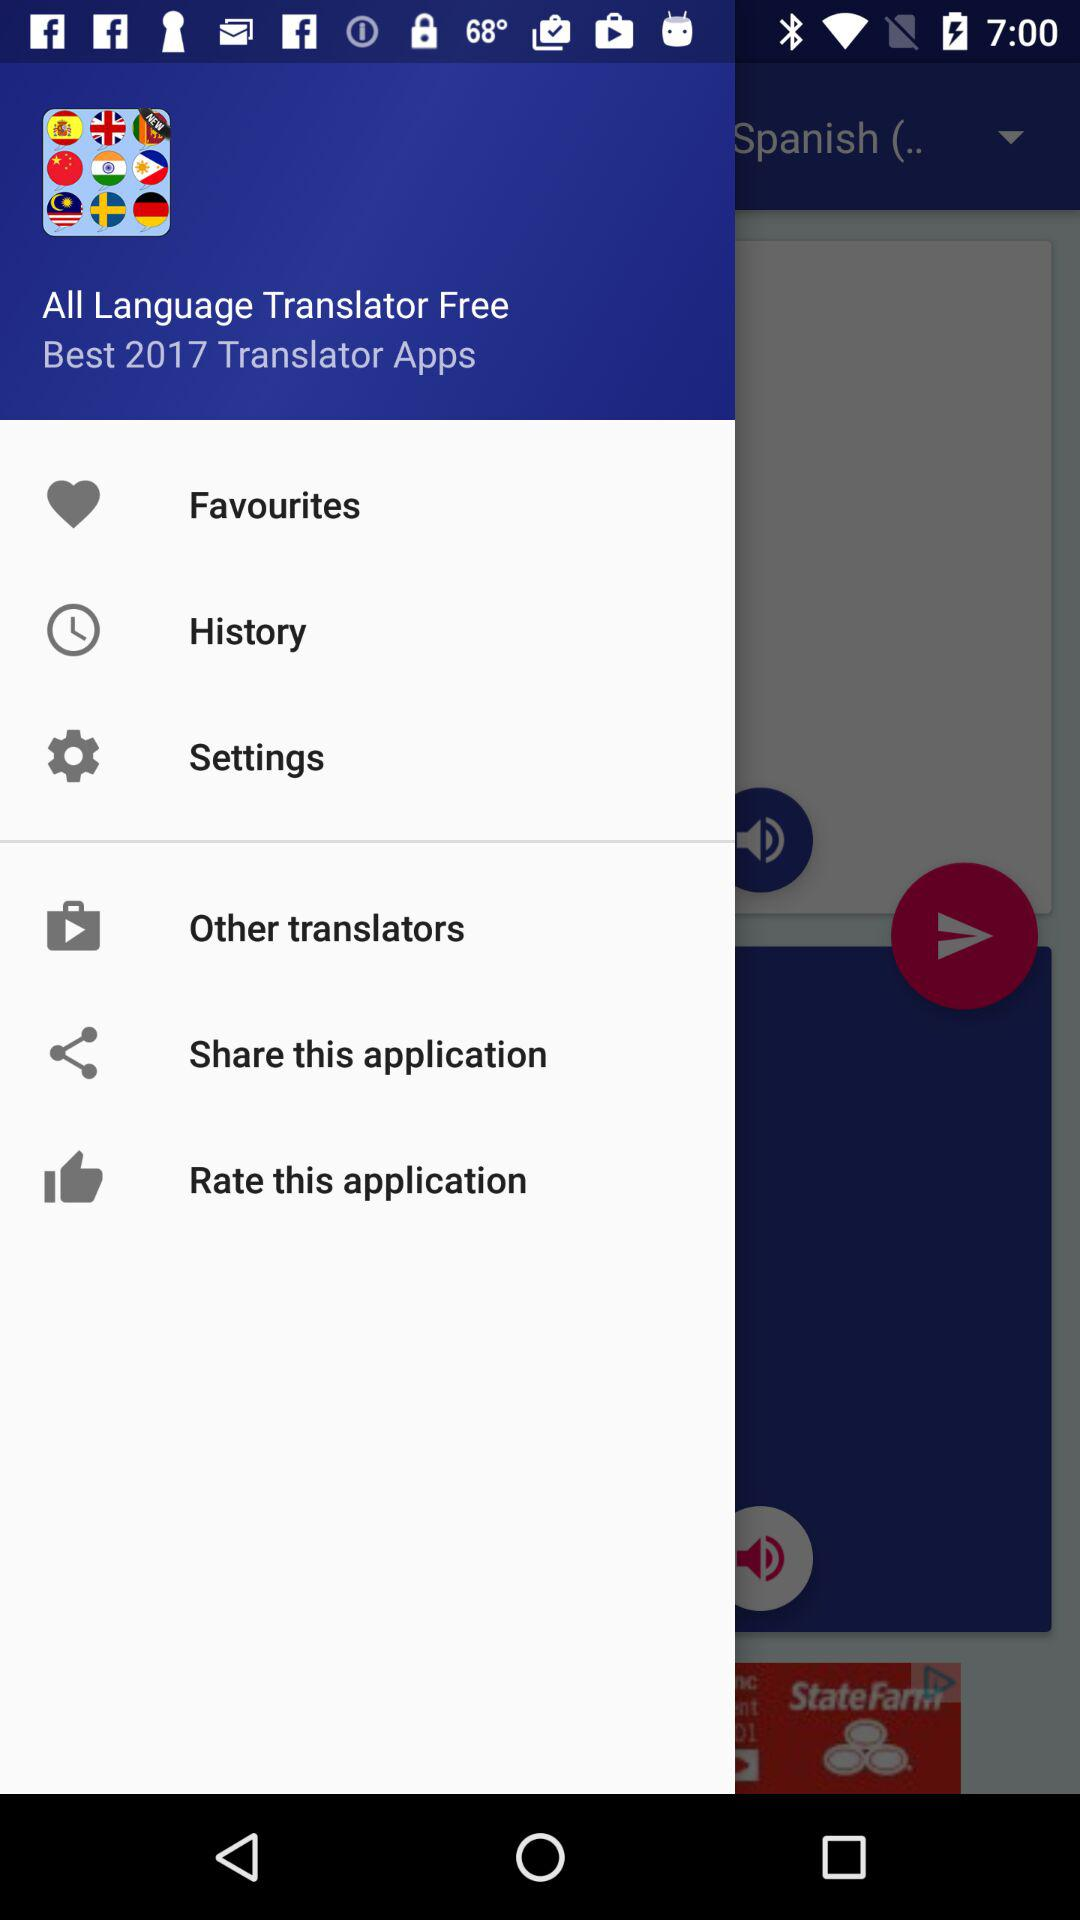What is the cost of the "All Language Translator"? It is free of cost. 